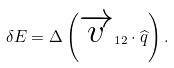<formula> <loc_0><loc_0><loc_500><loc_500>\delta E = \Delta \left ( \overrightarrow { v } _ { 1 2 } \cdot \widehat { q } \right ) .</formula> 